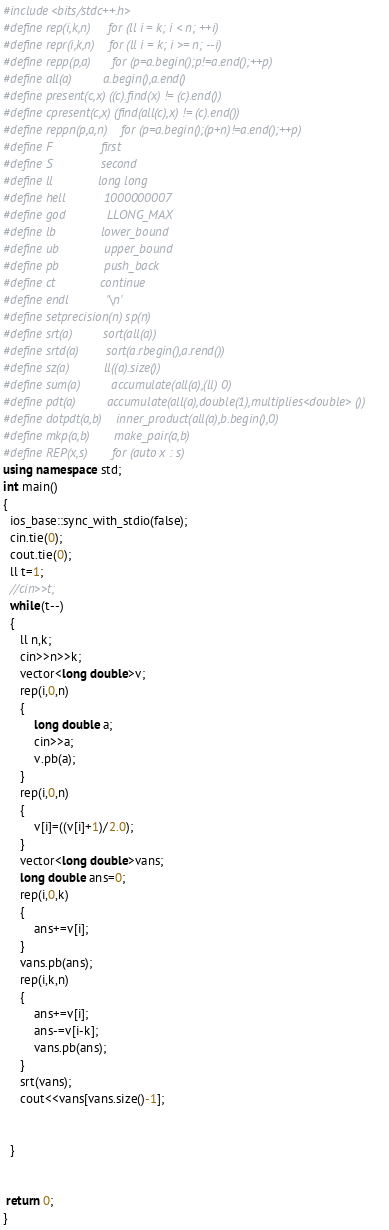Convert code to text. <code><loc_0><loc_0><loc_500><loc_500><_C++_>#include<bits/stdc++.h>
#define rep(i,k,n)     for (ll i = k; i < n; ++i)
#define repr(i,k,n)    for (ll i = k; i >= n; --i)
#define repp(p,a)      for (p=a.begin();p!=a.end();++p)
#define all(a)         a.begin(),a.end()
#define present(c,x) ((c).find(x) != (c).end())
#define cpresent(c,x) (find(all(c),x) != (c).end())
#define reppn(p,a,n)    for (p=a.begin();(p+n)!=a.end();++p)
#define F              first
#define S              second
#define ll             long long
#define hell           1000000007
#define god            LLONG_MAX
#define lb             lower_bound
#define ub             upper_bound
#define pb             push_back
#define ct             continue
#define endl           '\n'
#define setprecision(n) sp(n)
#define srt(a)         sort(all(a))
#define srtd(a)        sort(a.rbegin(),a.rend())
#define sz(a)          ll((a).size())
#define sum(a)         accumulate(all(a),(ll) 0)
#define pdt(a)         accumulate(all(a),double(1),multiplies<double> ())
#define dotpdt(a,b)    inner_product(all(a),b.begin(),0)
#define mkp(a,b)       make_pair(a,b)
#define REP(x,s)       for (auto x : s)
using namespace std;
int main()
{
  ios_base::sync_with_stdio(false);
  cin.tie(0);
  cout.tie(0);
  ll t=1;
  //cin>>t;
  while(t--)
  {
     ll n,k;
     cin>>n>>k;
     vector<long double>v;
     rep(i,0,n)
     {
         long double a;
         cin>>a;
         v.pb(a);
     }
     rep(i,0,n)
     {
         v[i]=((v[i]+1)/2.0);
     }
     vector<long double>vans;
     long double ans=0;
     rep(i,0,k)
     {
         ans+=v[i];
     }
     vans.pb(ans);
     rep(i,k,n)
     {
         ans+=v[i];
         ans-=v[i-k];
         vans.pb(ans);
     }
     srt(vans);
     cout<<vans[vans.size()-1];
     
     
  }      
 
 
 return 0;
}</code> 